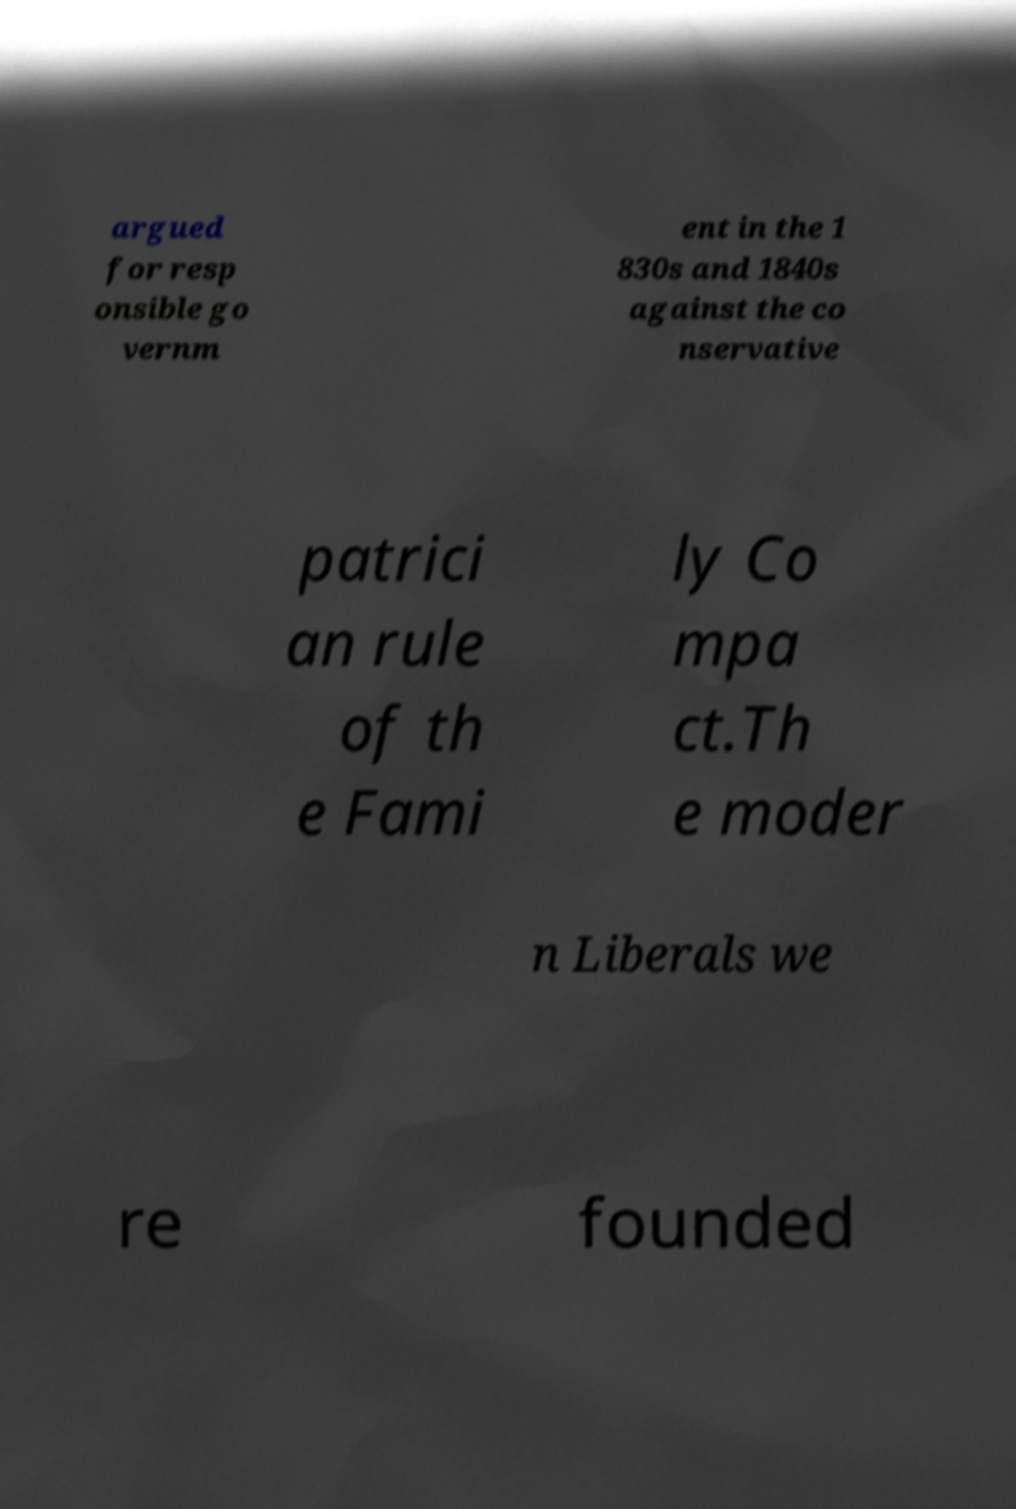Could you extract and type out the text from this image? argued for resp onsible go vernm ent in the 1 830s and 1840s against the co nservative patrici an rule of th e Fami ly Co mpa ct.Th e moder n Liberals we re founded 